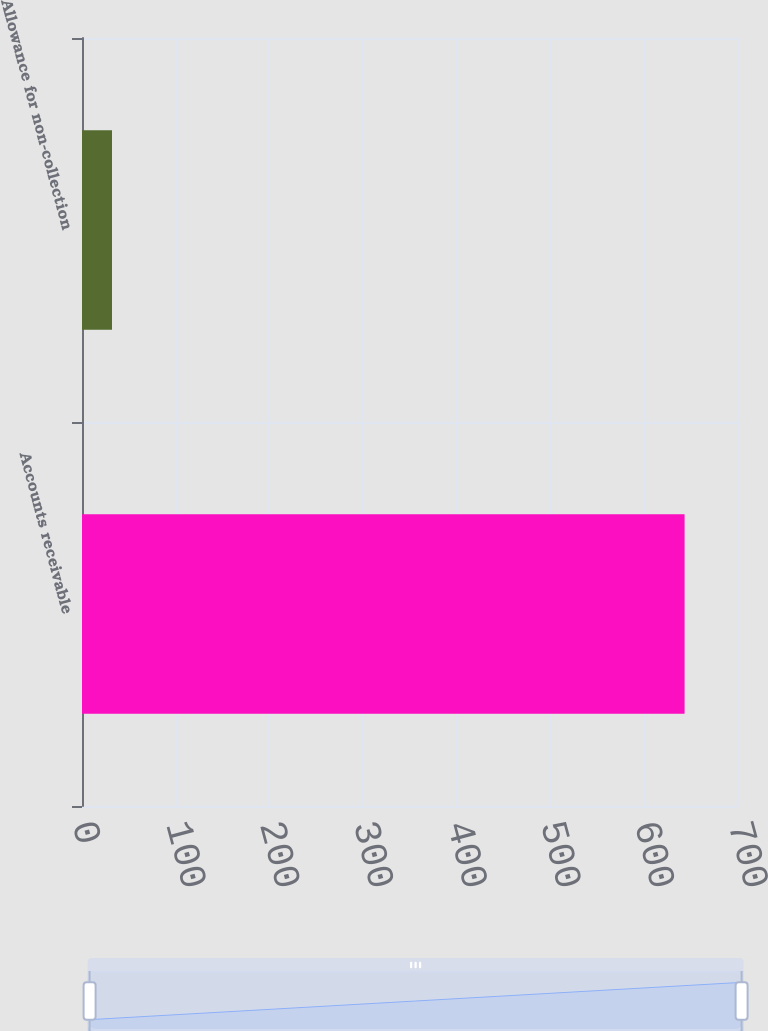Convert chart to OTSL. <chart><loc_0><loc_0><loc_500><loc_500><bar_chart><fcel>Accounts receivable<fcel>Allowance for non-collection<nl><fcel>643<fcel>32<nl></chart> 